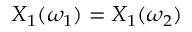Convert formula to latex. <formula><loc_0><loc_0><loc_500><loc_500>X _ { 1 } ( \omega _ { 1 } ) = X _ { 1 } ( \omega _ { 2 } )</formula> 